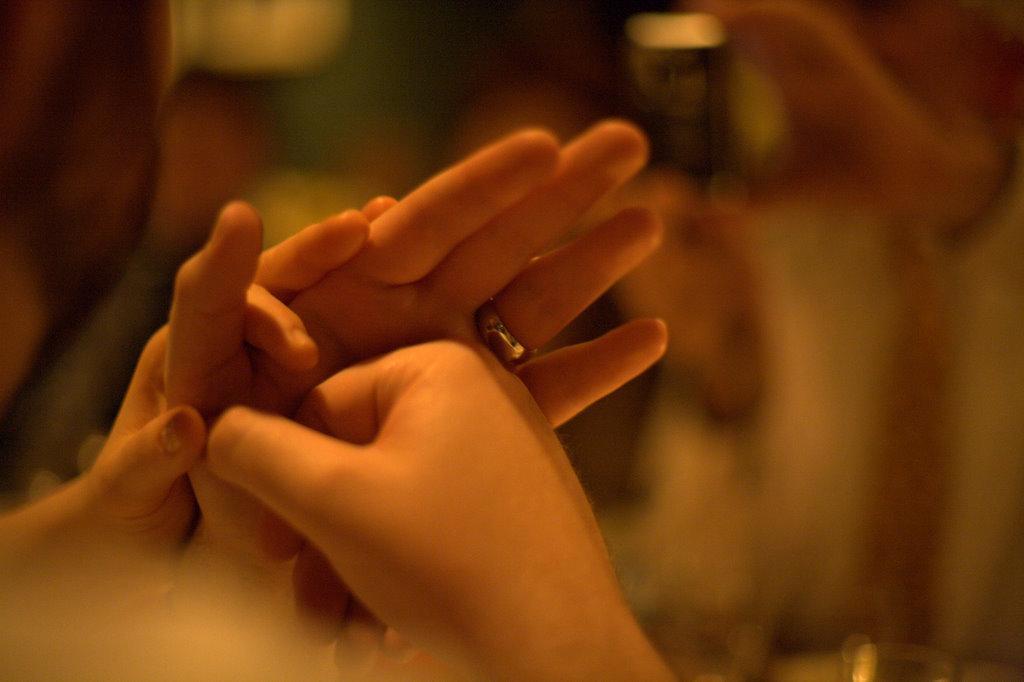Describe this image in one or two sentences. In this image I can see hands of two persons and I can see a ring which is silver in color to a hand. In the background I can see few blurry objects. 